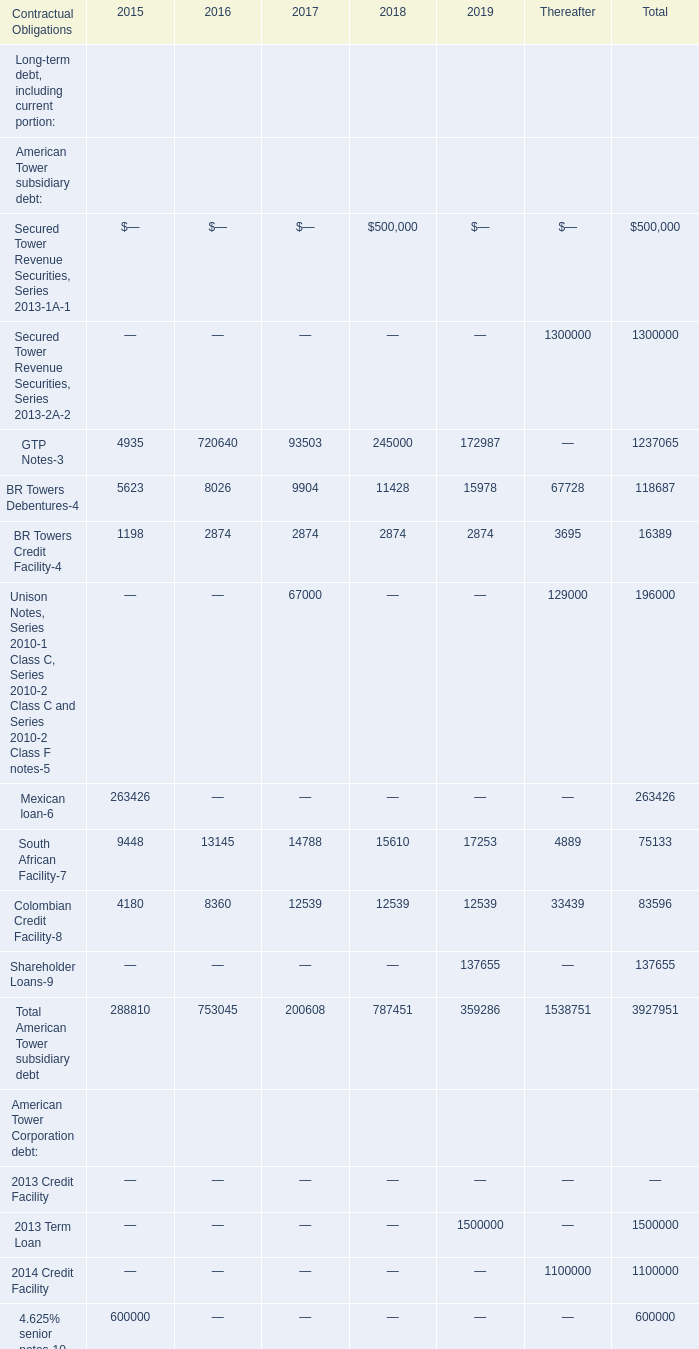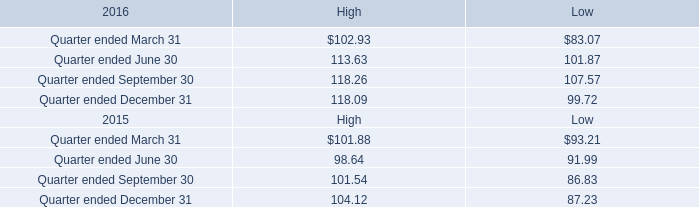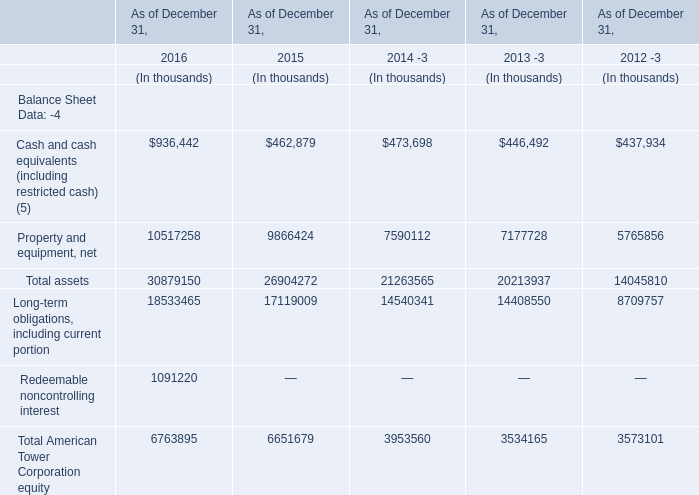For the year between 2018 and 2017 where Total American Tower subsidiary debt is the lowest, what's the increasing rate of American Tower subsidiary debt:South African Facility(7) ? 
Computations: ((14788 - 13145) / 13145)
Answer: 0.12499. 